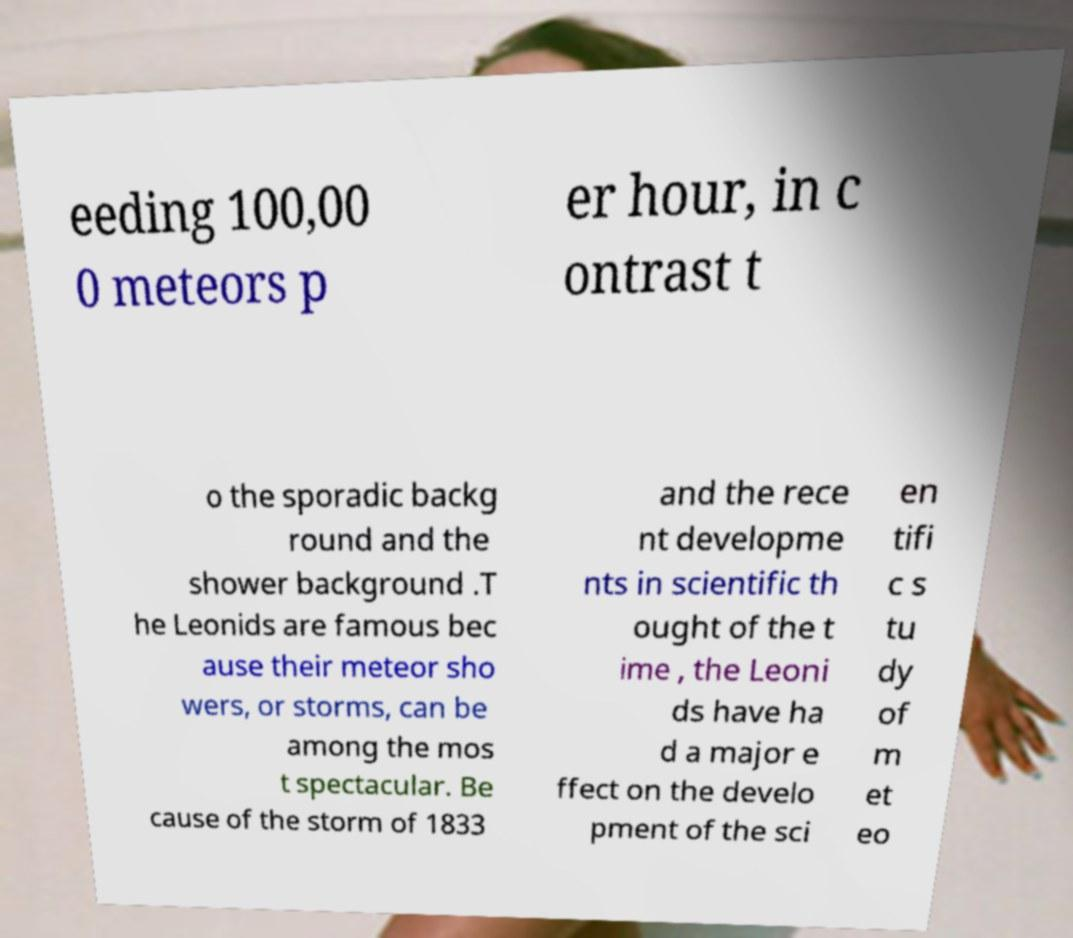Could you assist in decoding the text presented in this image and type it out clearly? eeding 100,00 0 meteors p er hour, in c ontrast t o the sporadic backg round and the shower background .T he Leonids are famous bec ause their meteor sho wers, or storms, can be among the mos t spectacular. Be cause of the storm of 1833 and the rece nt developme nts in scientific th ought of the t ime , the Leoni ds have ha d a major e ffect on the develo pment of the sci en tifi c s tu dy of m et eo 